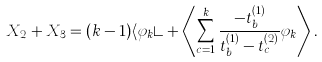<formula> <loc_0><loc_0><loc_500><loc_500>X _ { 2 } + X _ { 3 } = ( k - 1 ) \langle \varphi _ { k } \rangle + \left \langle \sum _ { c = 1 } ^ { k } \frac { - t _ { b } ^ { ( 1 ) } } { t _ { b } ^ { ( 1 ) } - t _ { c } ^ { ( 2 ) } } \varphi _ { k } \right \rangle .</formula> 